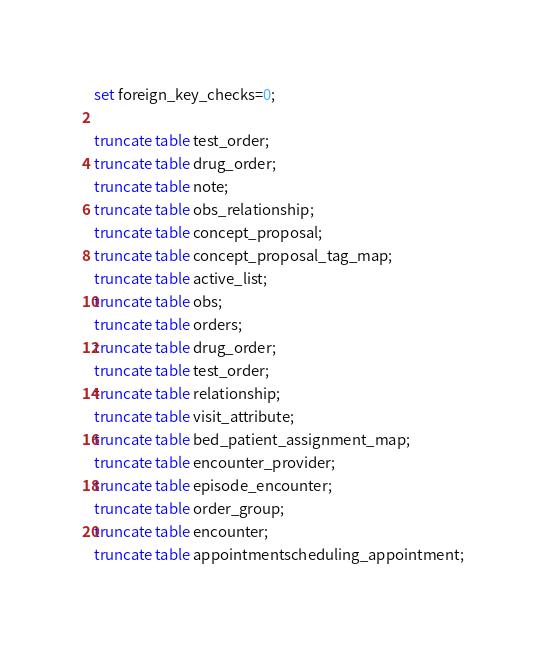<code> <loc_0><loc_0><loc_500><loc_500><_SQL_>set foreign_key_checks=0;

truncate table test_order;
truncate table drug_order;
truncate table note;   
truncate table obs_relationship;  
truncate table concept_proposal;  	
truncate table concept_proposal_tag_map;
truncate table active_list;   
truncate table obs;
truncate table orders;
truncate table drug_order; 
truncate table test_order; 
truncate table relationship;
truncate table visit_attribute;
truncate table bed_patient_assignment_map;
truncate table encounter_provider;
truncate table episode_encounter;
truncate table order_group;
truncate table encounter;  
truncate table appointmentscheduling_appointment;</code> 